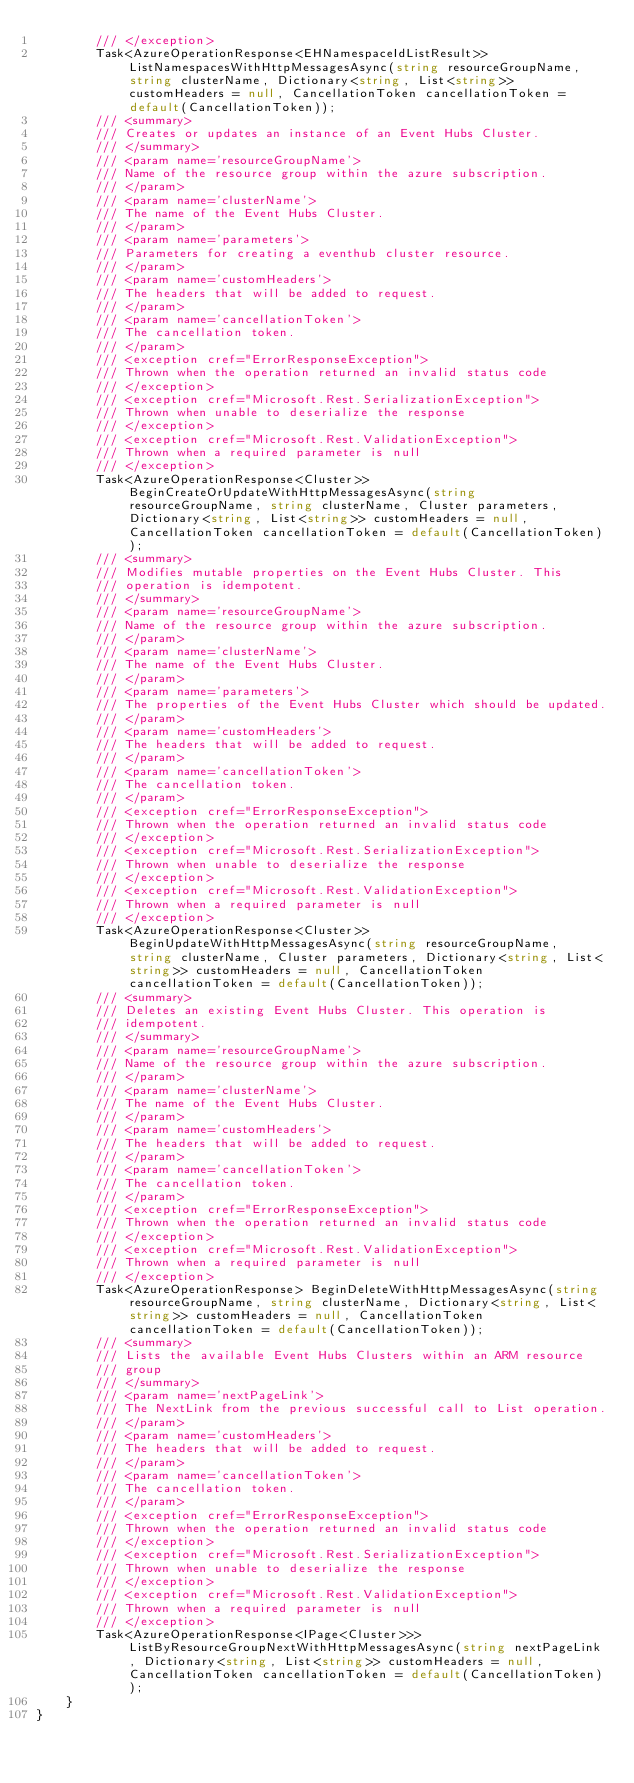Convert code to text. <code><loc_0><loc_0><loc_500><loc_500><_C#_>        /// </exception>
        Task<AzureOperationResponse<EHNamespaceIdListResult>> ListNamespacesWithHttpMessagesAsync(string resourceGroupName, string clusterName, Dictionary<string, List<string>> customHeaders = null, CancellationToken cancellationToken = default(CancellationToken));
        /// <summary>
        /// Creates or updates an instance of an Event Hubs Cluster.
        /// </summary>
        /// <param name='resourceGroupName'>
        /// Name of the resource group within the azure subscription.
        /// </param>
        /// <param name='clusterName'>
        /// The name of the Event Hubs Cluster.
        /// </param>
        /// <param name='parameters'>
        /// Parameters for creating a eventhub cluster resource.
        /// </param>
        /// <param name='customHeaders'>
        /// The headers that will be added to request.
        /// </param>
        /// <param name='cancellationToken'>
        /// The cancellation token.
        /// </param>
        /// <exception cref="ErrorResponseException">
        /// Thrown when the operation returned an invalid status code
        /// </exception>
        /// <exception cref="Microsoft.Rest.SerializationException">
        /// Thrown when unable to deserialize the response
        /// </exception>
        /// <exception cref="Microsoft.Rest.ValidationException">
        /// Thrown when a required parameter is null
        /// </exception>
        Task<AzureOperationResponse<Cluster>> BeginCreateOrUpdateWithHttpMessagesAsync(string resourceGroupName, string clusterName, Cluster parameters, Dictionary<string, List<string>> customHeaders = null, CancellationToken cancellationToken = default(CancellationToken));
        /// <summary>
        /// Modifies mutable properties on the Event Hubs Cluster. This
        /// operation is idempotent.
        /// </summary>
        /// <param name='resourceGroupName'>
        /// Name of the resource group within the azure subscription.
        /// </param>
        /// <param name='clusterName'>
        /// The name of the Event Hubs Cluster.
        /// </param>
        /// <param name='parameters'>
        /// The properties of the Event Hubs Cluster which should be updated.
        /// </param>
        /// <param name='customHeaders'>
        /// The headers that will be added to request.
        /// </param>
        /// <param name='cancellationToken'>
        /// The cancellation token.
        /// </param>
        /// <exception cref="ErrorResponseException">
        /// Thrown when the operation returned an invalid status code
        /// </exception>
        /// <exception cref="Microsoft.Rest.SerializationException">
        /// Thrown when unable to deserialize the response
        /// </exception>
        /// <exception cref="Microsoft.Rest.ValidationException">
        /// Thrown when a required parameter is null
        /// </exception>
        Task<AzureOperationResponse<Cluster>> BeginUpdateWithHttpMessagesAsync(string resourceGroupName, string clusterName, Cluster parameters, Dictionary<string, List<string>> customHeaders = null, CancellationToken cancellationToken = default(CancellationToken));
        /// <summary>
        /// Deletes an existing Event Hubs Cluster. This operation is
        /// idempotent.
        /// </summary>
        /// <param name='resourceGroupName'>
        /// Name of the resource group within the azure subscription.
        /// </param>
        /// <param name='clusterName'>
        /// The name of the Event Hubs Cluster.
        /// </param>
        /// <param name='customHeaders'>
        /// The headers that will be added to request.
        /// </param>
        /// <param name='cancellationToken'>
        /// The cancellation token.
        /// </param>
        /// <exception cref="ErrorResponseException">
        /// Thrown when the operation returned an invalid status code
        /// </exception>
        /// <exception cref="Microsoft.Rest.ValidationException">
        /// Thrown when a required parameter is null
        /// </exception>
        Task<AzureOperationResponse> BeginDeleteWithHttpMessagesAsync(string resourceGroupName, string clusterName, Dictionary<string, List<string>> customHeaders = null, CancellationToken cancellationToken = default(CancellationToken));
        /// <summary>
        /// Lists the available Event Hubs Clusters within an ARM resource
        /// group
        /// </summary>
        /// <param name='nextPageLink'>
        /// The NextLink from the previous successful call to List operation.
        /// </param>
        /// <param name='customHeaders'>
        /// The headers that will be added to request.
        /// </param>
        /// <param name='cancellationToken'>
        /// The cancellation token.
        /// </param>
        /// <exception cref="ErrorResponseException">
        /// Thrown when the operation returned an invalid status code
        /// </exception>
        /// <exception cref="Microsoft.Rest.SerializationException">
        /// Thrown when unable to deserialize the response
        /// </exception>
        /// <exception cref="Microsoft.Rest.ValidationException">
        /// Thrown when a required parameter is null
        /// </exception>
        Task<AzureOperationResponse<IPage<Cluster>>> ListByResourceGroupNextWithHttpMessagesAsync(string nextPageLink, Dictionary<string, List<string>> customHeaders = null, CancellationToken cancellationToken = default(CancellationToken));
    }
}
</code> 